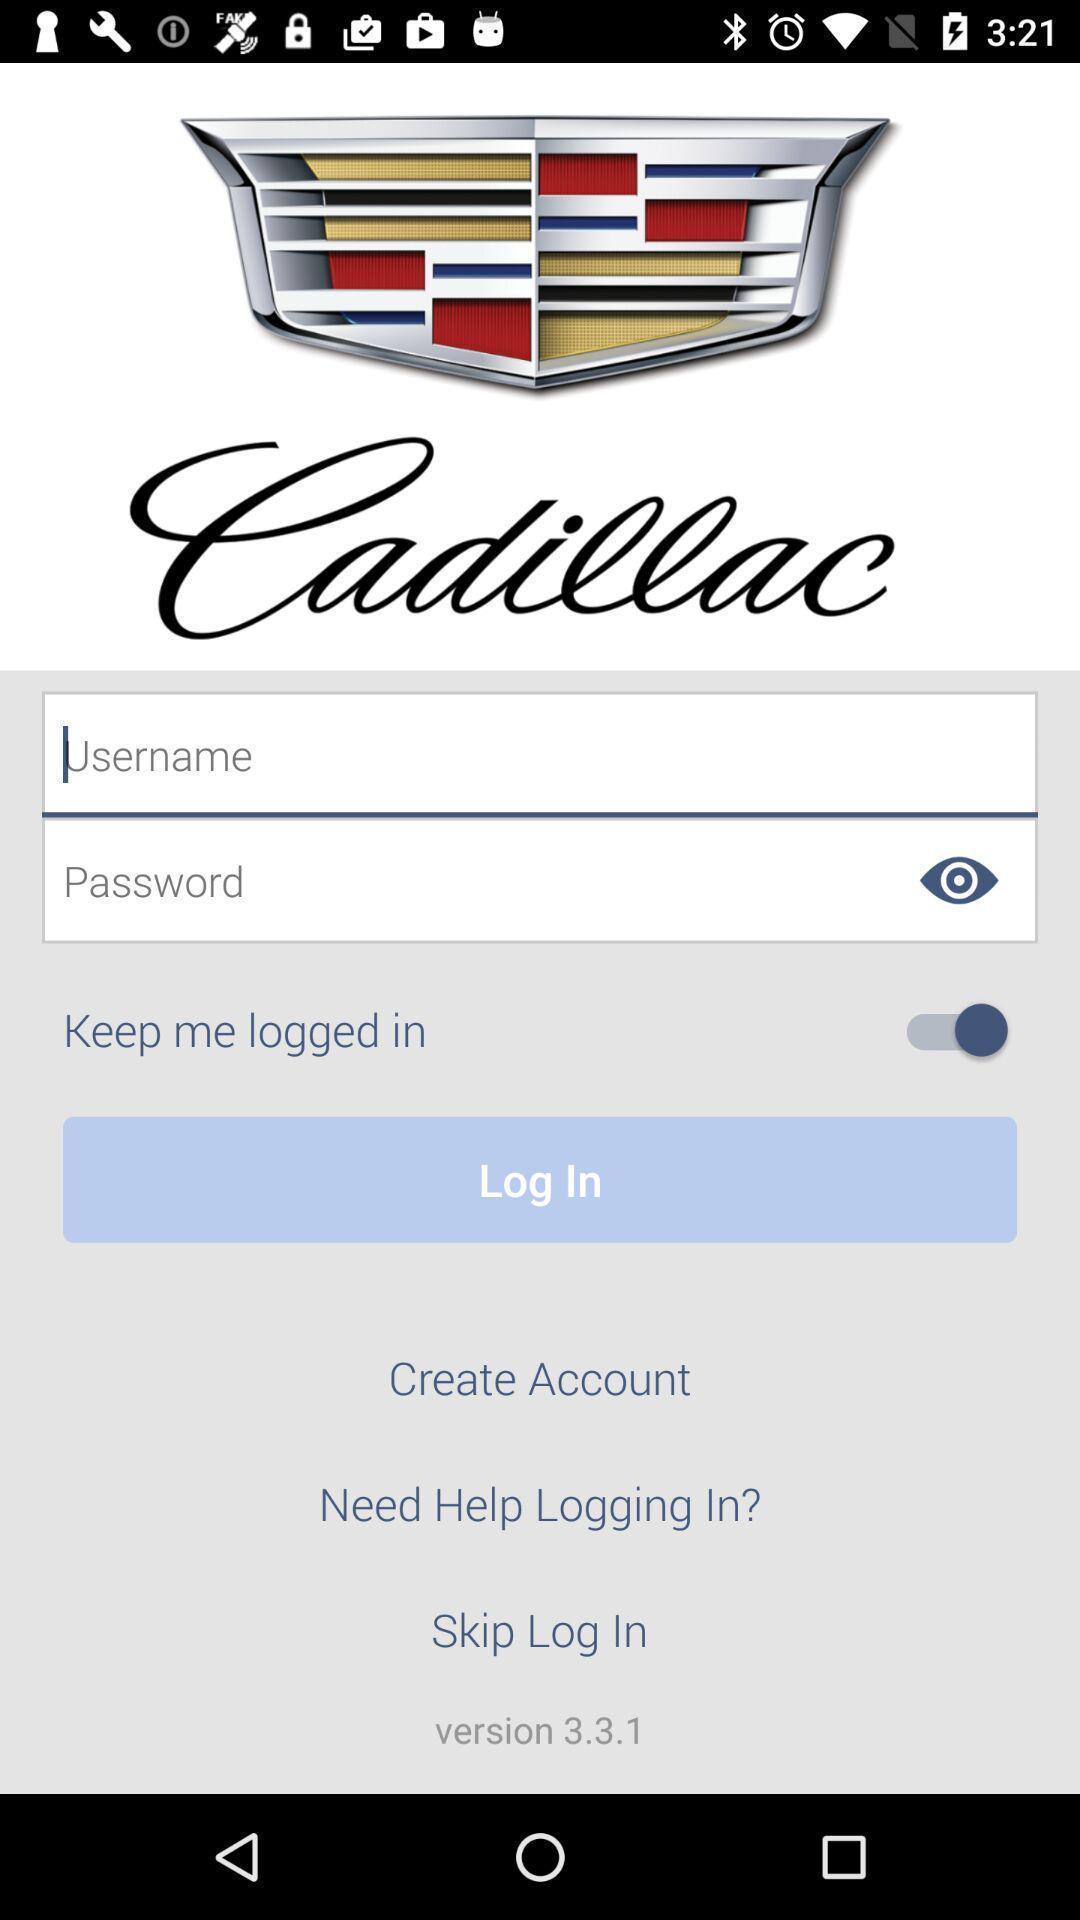Give me a narrative description of this picture. Welcome to the login page. 